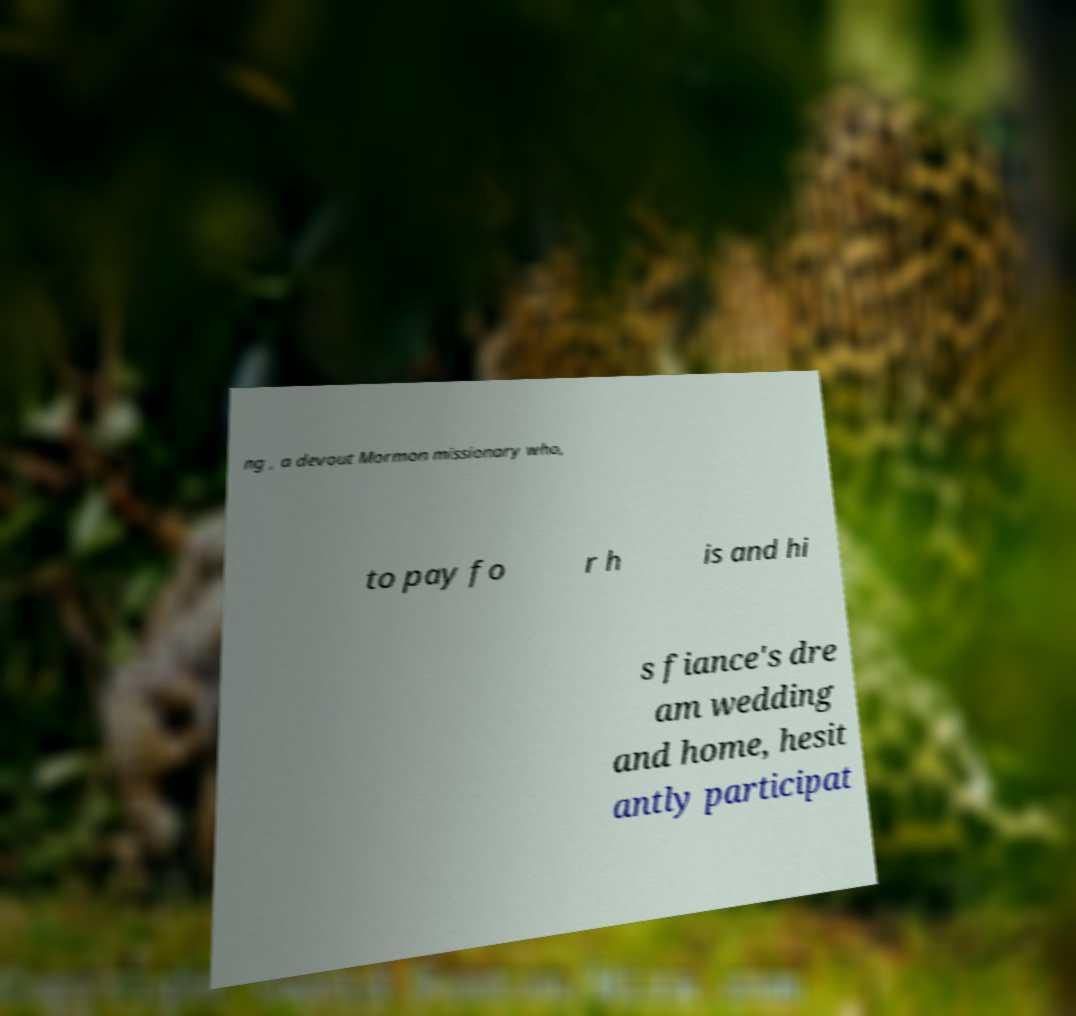What messages or text are displayed in this image? I need them in a readable, typed format. ng , a devout Mormon missionary who, to pay fo r h is and hi s fiance's dre am wedding and home, hesit antly participat 